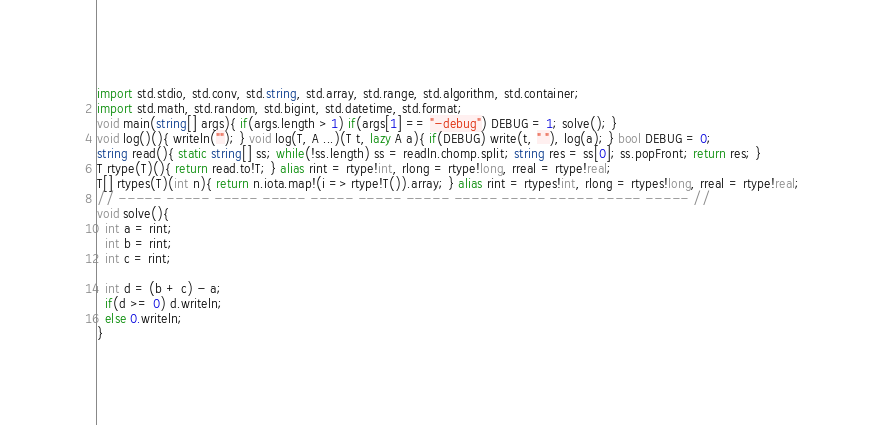Convert code to text. <code><loc_0><loc_0><loc_500><loc_500><_D_>import std.stdio, std.conv, std.string, std.array, std.range, std.algorithm, std.container;
import std.math, std.random, std.bigint, std.datetime, std.format;
void main(string[] args){ if(args.length > 1) if(args[1] == "-debug") DEBUG = 1; solve(); }
void log()(){ writeln(""); } void log(T, A ...)(T t, lazy A a){ if(DEBUG) write(t, " "), log(a); } bool DEBUG = 0;
string read(){ static string[] ss; while(!ss.length) ss = readln.chomp.split; string res = ss[0]; ss.popFront; return res; }
T rtype(T)(){ return read.to!T; } alias rint = rtype!int, rlong = rtype!long, rreal = rtype!real;
T[] rtypes(T)(int n){ return n.iota.map!(i => rtype!T()).array; } alias rint = rtypes!int, rlong = rtypes!long, rreal = rtype!real;
// ----- ----- ----- ----- ----- ----- ----- ----- ----- ----- ----- ----- //
void solve(){
  int a = rint;
  int b = rint;
  int c = rint;
  
  int d = (b + c) - a;
  if(d >= 0) d.writeln;
  else 0.writeln;
}</code> 